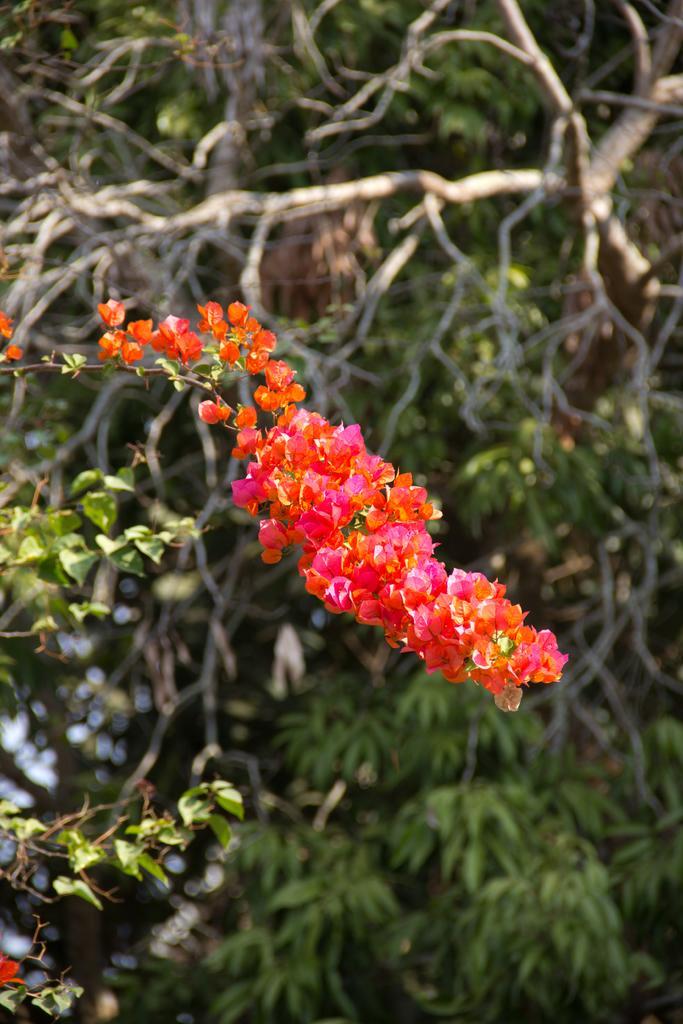Can you describe this image briefly? In this image I can see flower and tree and leaves. 